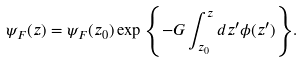<formula> <loc_0><loc_0><loc_500><loc_500>\psi _ { F } ( z ) = \psi _ { F } ( z _ { 0 } ) \exp { \left \{ - G \int _ { z _ { 0 } } ^ { z } d z ^ { \prime } \phi ( z ^ { \prime } ) \right \} } .</formula> 